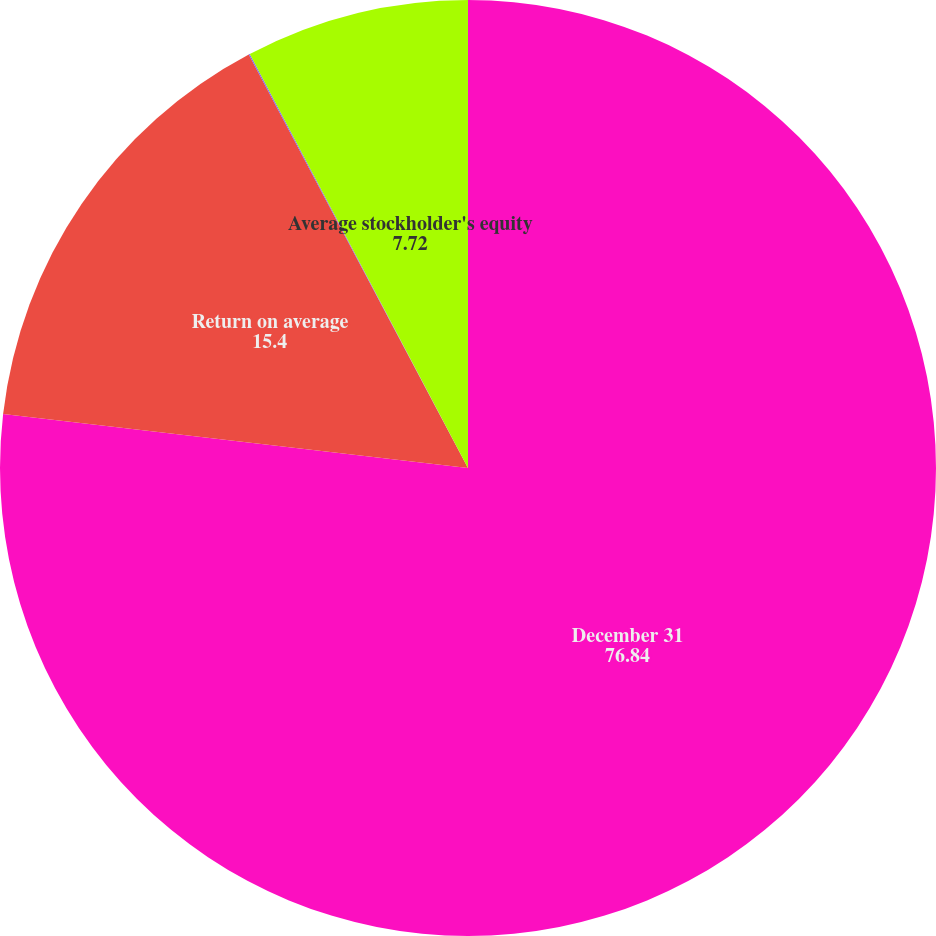<chart> <loc_0><loc_0><loc_500><loc_500><pie_chart><fcel>December 31<fcel>Return on average<fcel>Return on average total assets<fcel>Average stockholder's equity<nl><fcel>76.84%<fcel>15.4%<fcel>0.04%<fcel>7.72%<nl></chart> 